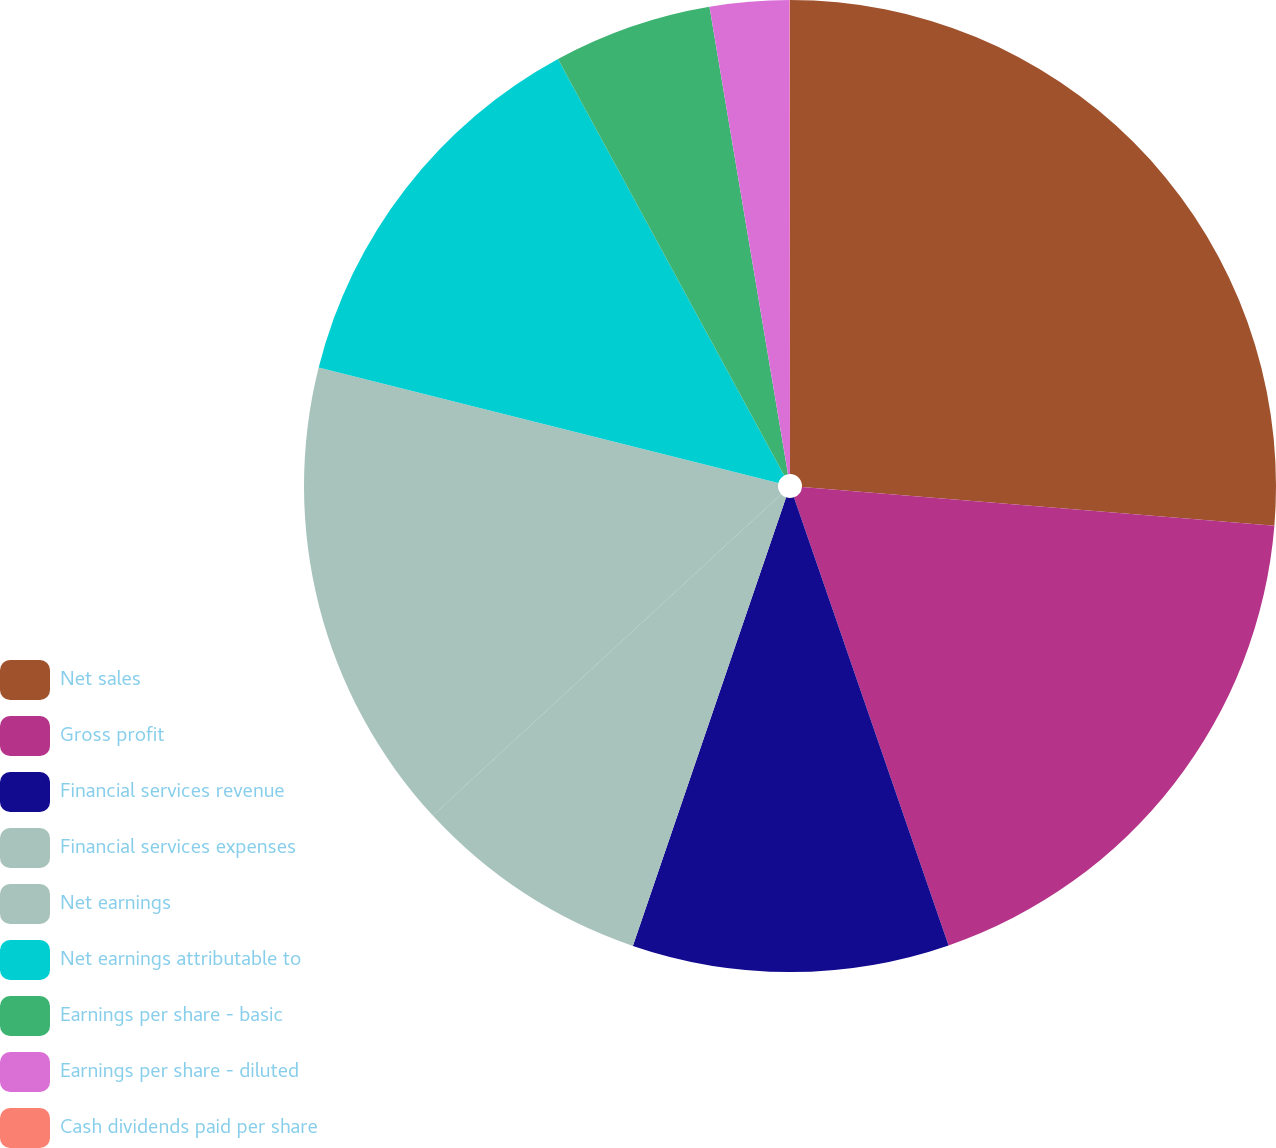Convert chart. <chart><loc_0><loc_0><loc_500><loc_500><pie_chart><fcel>Net sales<fcel>Gross profit<fcel>Financial services revenue<fcel>Financial services expenses<fcel>Net earnings<fcel>Net earnings attributable to<fcel>Earnings per share - basic<fcel>Earnings per share - diluted<fcel>Cash dividends paid per share<nl><fcel>26.3%<fcel>18.41%<fcel>10.53%<fcel>7.9%<fcel>15.78%<fcel>13.16%<fcel>5.27%<fcel>2.64%<fcel>0.01%<nl></chart> 